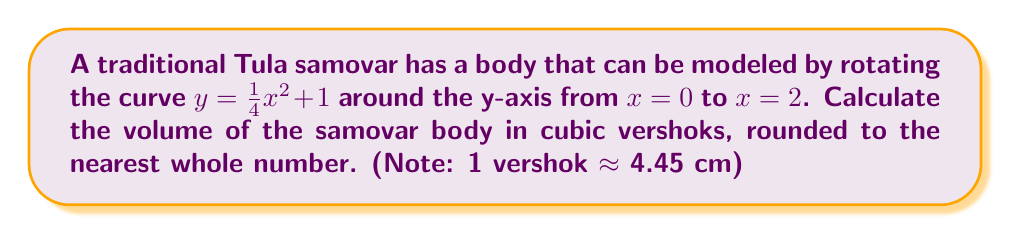Provide a solution to this math problem. To calculate the volume of the samovar body, we'll use the method of rotation (shell method) around the y-axis.

1) The formula for the volume using the shell method is:
   $$V = 2\pi \int_a^b x f(x) dx$$

2) In our case, $f(x) = \frac{1}{4}x^2 + 1$, $a = 0$, and $b = 2$

3) Substituting into the formula:
   $$V = 2\pi \int_0^2 x (\frac{1}{4}x^2 + 1) dx$$

4) Expanding the integrand:
   $$V = 2\pi \int_0^2 (\frac{1}{4}x^3 + x) dx$$

5) Integrating:
   $$V = 2\pi [\frac{1}{16}x^4 + \frac{1}{2}x^2]_0^2$$

6) Evaluating the integral:
   $$V = 2\pi [(\frac{1}{16}(2^4) + \frac{1}{2}(2^2)) - (\frac{1}{16}(0^4) + \frac{1}{2}(0^2))]$$
   $$V = 2\pi [\frac{1}{16}(16) + \frac{1}{2}(4) - 0]$$
   $$V = 2\pi [1 + 2]$$
   $$V = 2\pi (3)$$
   $$V = 6\pi$$

7) Converting to cubic vershoks (approximating π ≈ 3.14159):
   $$V \approx 6 * 3.14159 \approx 18.85 \text{ cubic vershoks}$$

8) Rounding to the nearest whole number:
   $$V \approx 19 \text{ cubic vershoks}$$
Answer: 19 cubic vershoks 